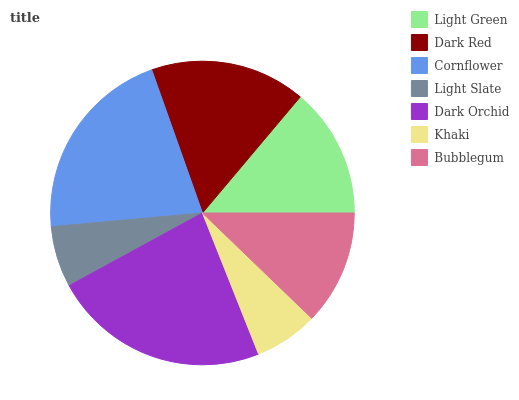Is Light Slate the minimum?
Answer yes or no. Yes. Is Dark Orchid the maximum?
Answer yes or no. Yes. Is Dark Red the minimum?
Answer yes or no. No. Is Dark Red the maximum?
Answer yes or no. No. Is Dark Red greater than Light Green?
Answer yes or no. Yes. Is Light Green less than Dark Red?
Answer yes or no. Yes. Is Light Green greater than Dark Red?
Answer yes or no. No. Is Dark Red less than Light Green?
Answer yes or no. No. Is Light Green the high median?
Answer yes or no. Yes. Is Light Green the low median?
Answer yes or no. Yes. Is Light Slate the high median?
Answer yes or no. No. Is Bubblegum the low median?
Answer yes or no. No. 